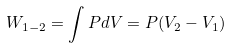Convert formula to latex. <formula><loc_0><loc_0><loc_500><loc_500>W _ { 1 - 2 } = \int P d V = P ( V _ { 2 } - V _ { 1 } )</formula> 